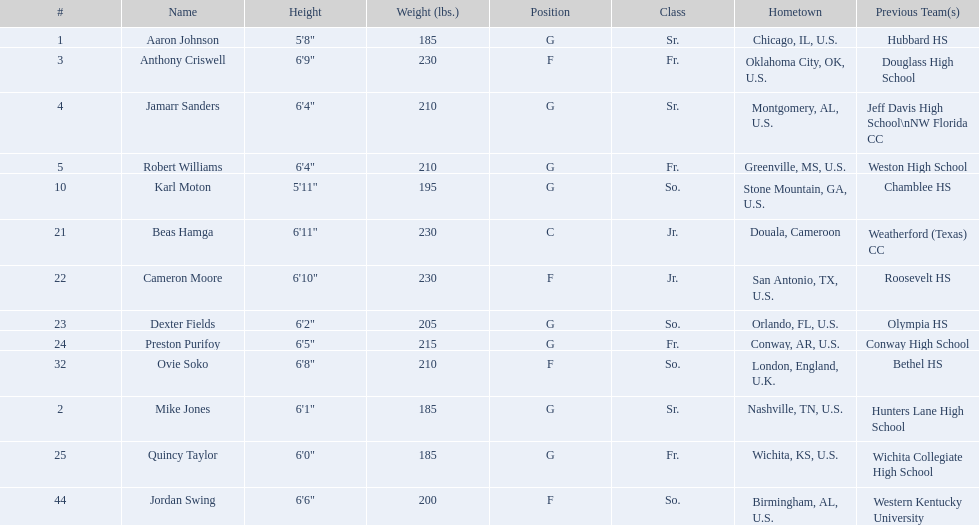What was the number of players on the 2010-11 uab blazers men's basketball team? 13. 